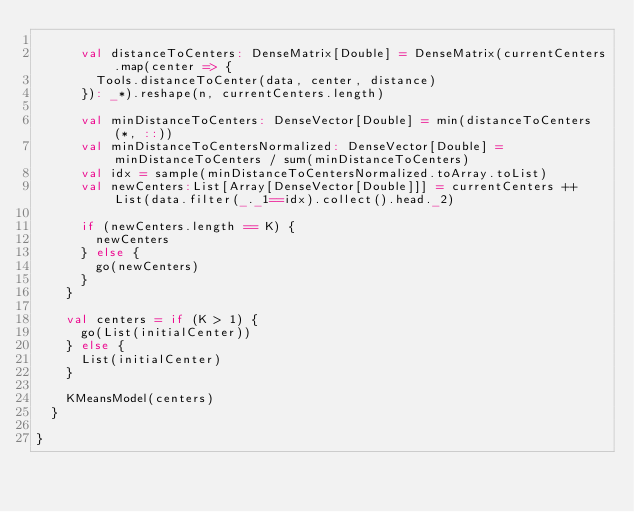Convert code to text. <code><loc_0><loc_0><loc_500><loc_500><_Scala_>
      val distanceToCenters: DenseMatrix[Double] = DenseMatrix(currentCenters.map(center => {
        Tools.distanceToCenter(data, center, distance)
      }): _*).reshape(n, currentCenters.length)

      val minDistanceToCenters: DenseVector[Double] = min(distanceToCenters(*, ::))
      val minDistanceToCentersNormalized: DenseVector[Double] = minDistanceToCenters / sum(minDistanceToCenters)
      val idx = sample(minDistanceToCentersNormalized.toArray.toList)
      val newCenters:List[Array[DenseVector[Double]]] = currentCenters ++ List(data.filter(_._1==idx).collect().head._2)

      if (newCenters.length == K) {
        newCenters
      } else {
        go(newCenters)
      }
    }

    val centers = if (K > 1) {
      go(List(initialCenter))
    } else {
      List(initialCenter)
    }

    KMeansModel(centers)
  }

}

</code> 